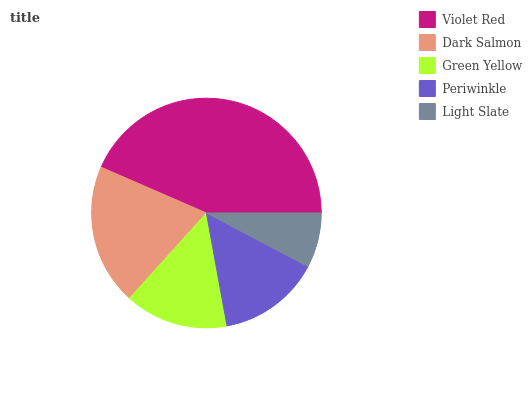Is Light Slate the minimum?
Answer yes or no. Yes. Is Violet Red the maximum?
Answer yes or no. Yes. Is Dark Salmon the minimum?
Answer yes or no. No. Is Dark Salmon the maximum?
Answer yes or no. No. Is Violet Red greater than Dark Salmon?
Answer yes or no. Yes. Is Dark Salmon less than Violet Red?
Answer yes or no. Yes. Is Dark Salmon greater than Violet Red?
Answer yes or no. No. Is Violet Red less than Dark Salmon?
Answer yes or no. No. Is Green Yellow the high median?
Answer yes or no. Yes. Is Green Yellow the low median?
Answer yes or no. Yes. Is Dark Salmon the high median?
Answer yes or no. No. Is Periwinkle the low median?
Answer yes or no. No. 